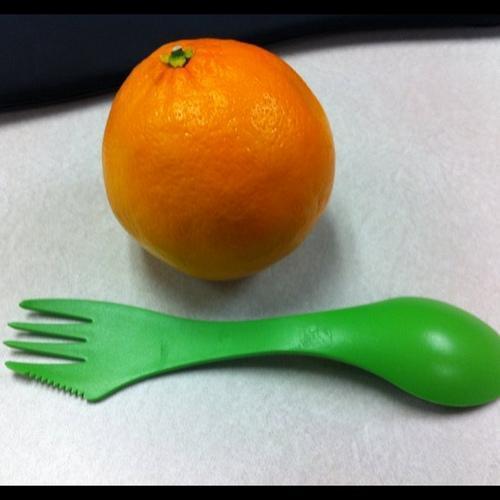How many oranges are shown?
Give a very brief answer. 1. 